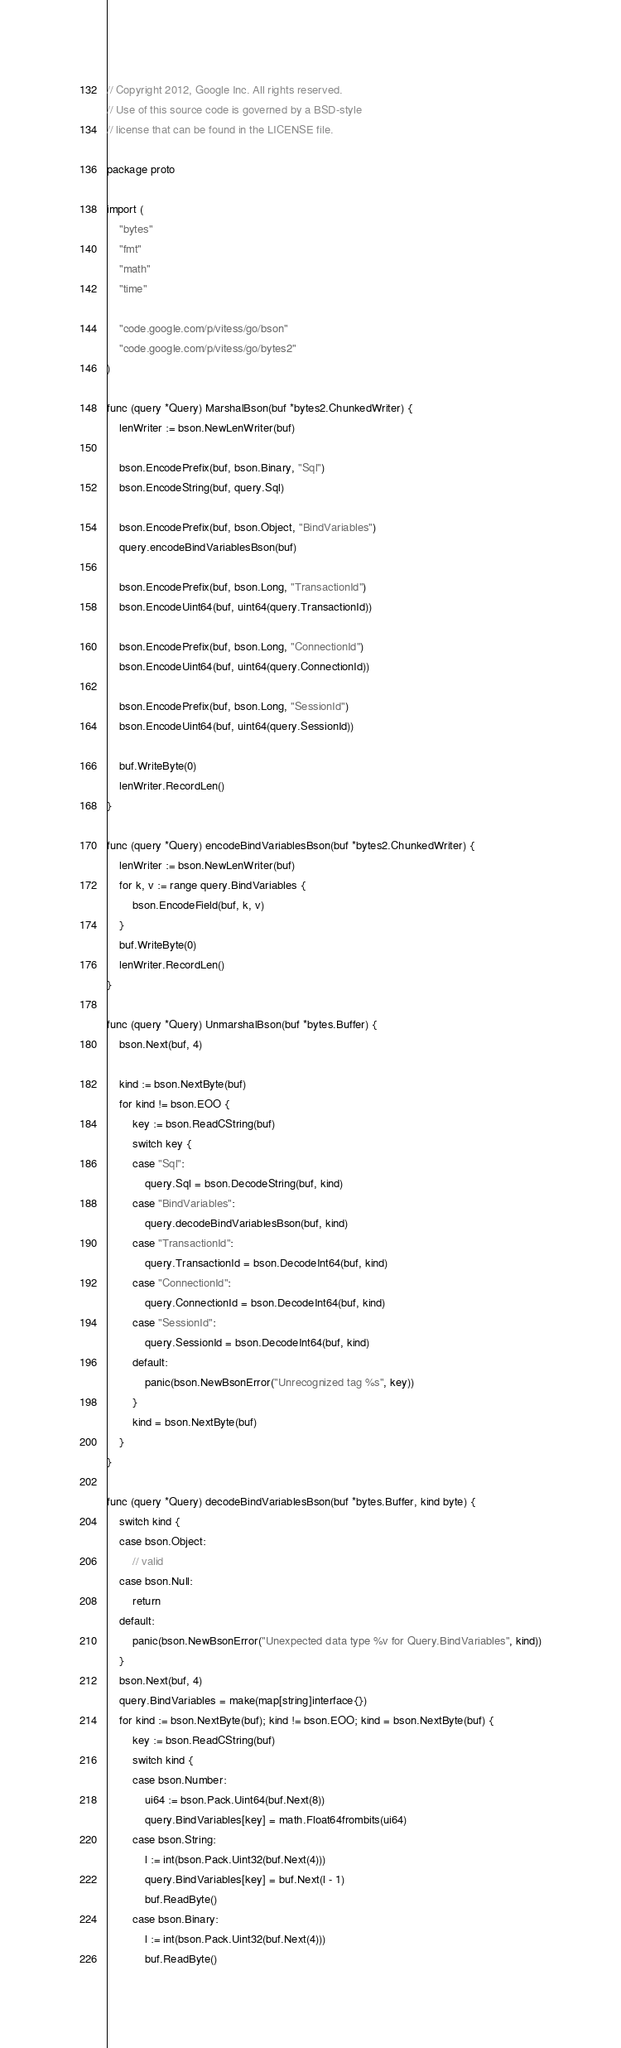Convert code to text. <code><loc_0><loc_0><loc_500><loc_500><_Go_>// Copyright 2012, Google Inc. All rights reserved.
// Use of this source code is governed by a BSD-style
// license that can be found in the LICENSE file.

package proto

import (
	"bytes"
	"fmt"
	"math"
	"time"

	"code.google.com/p/vitess/go/bson"
	"code.google.com/p/vitess/go/bytes2"
)

func (query *Query) MarshalBson(buf *bytes2.ChunkedWriter) {
	lenWriter := bson.NewLenWriter(buf)

	bson.EncodePrefix(buf, bson.Binary, "Sql")
	bson.EncodeString(buf, query.Sql)

	bson.EncodePrefix(buf, bson.Object, "BindVariables")
	query.encodeBindVariablesBson(buf)

	bson.EncodePrefix(buf, bson.Long, "TransactionId")
	bson.EncodeUint64(buf, uint64(query.TransactionId))

	bson.EncodePrefix(buf, bson.Long, "ConnectionId")
	bson.EncodeUint64(buf, uint64(query.ConnectionId))

	bson.EncodePrefix(buf, bson.Long, "SessionId")
	bson.EncodeUint64(buf, uint64(query.SessionId))

	buf.WriteByte(0)
	lenWriter.RecordLen()
}

func (query *Query) encodeBindVariablesBson(buf *bytes2.ChunkedWriter) {
	lenWriter := bson.NewLenWriter(buf)
	for k, v := range query.BindVariables {
		bson.EncodeField(buf, k, v)
	}
	buf.WriteByte(0)
	lenWriter.RecordLen()
}

func (query *Query) UnmarshalBson(buf *bytes.Buffer) {
	bson.Next(buf, 4)

	kind := bson.NextByte(buf)
	for kind != bson.EOO {
		key := bson.ReadCString(buf)
		switch key {
		case "Sql":
			query.Sql = bson.DecodeString(buf, kind)
		case "BindVariables":
			query.decodeBindVariablesBson(buf, kind)
		case "TransactionId":
			query.TransactionId = bson.DecodeInt64(buf, kind)
		case "ConnectionId":
			query.ConnectionId = bson.DecodeInt64(buf, kind)
		case "SessionId":
			query.SessionId = bson.DecodeInt64(buf, kind)
		default:
			panic(bson.NewBsonError("Unrecognized tag %s", key))
		}
		kind = bson.NextByte(buf)
	}
}

func (query *Query) decodeBindVariablesBson(buf *bytes.Buffer, kind byte) {
	switch kind {
	case bson.Object:
		// valid
	case bson.Null:
		return
	default:
		panic(bson.NewBsonError("Unexpected data type %v for Query.BindVariables", kind))
	}
	bson.Next(buf, 4)
	query.BindVariables = make(map[string]interface{})
	for kind := bson.NextByte(buf); kind != bson.EOO; kind = bson.NextByte(buf) {
		key := bson.ReadCString(buf)
		switch kind {
		case bson.Number:
			ui64 := bson.Pack.Uint64(buf.Next(8))
			query.BindVariables[key] = math.Float64frombits(ui64)
		case bson.String:
			l := int(bson.Pack.Uint32(buf.Next(4)))
			query.BindVariables[key] = buf.Next(l - 1)
			buf.ReadByte()
		case bson.Binary:
			l := int(bson.Pack.Uint32(buf.Next(4)))
			buf.ReadByte()</code> 